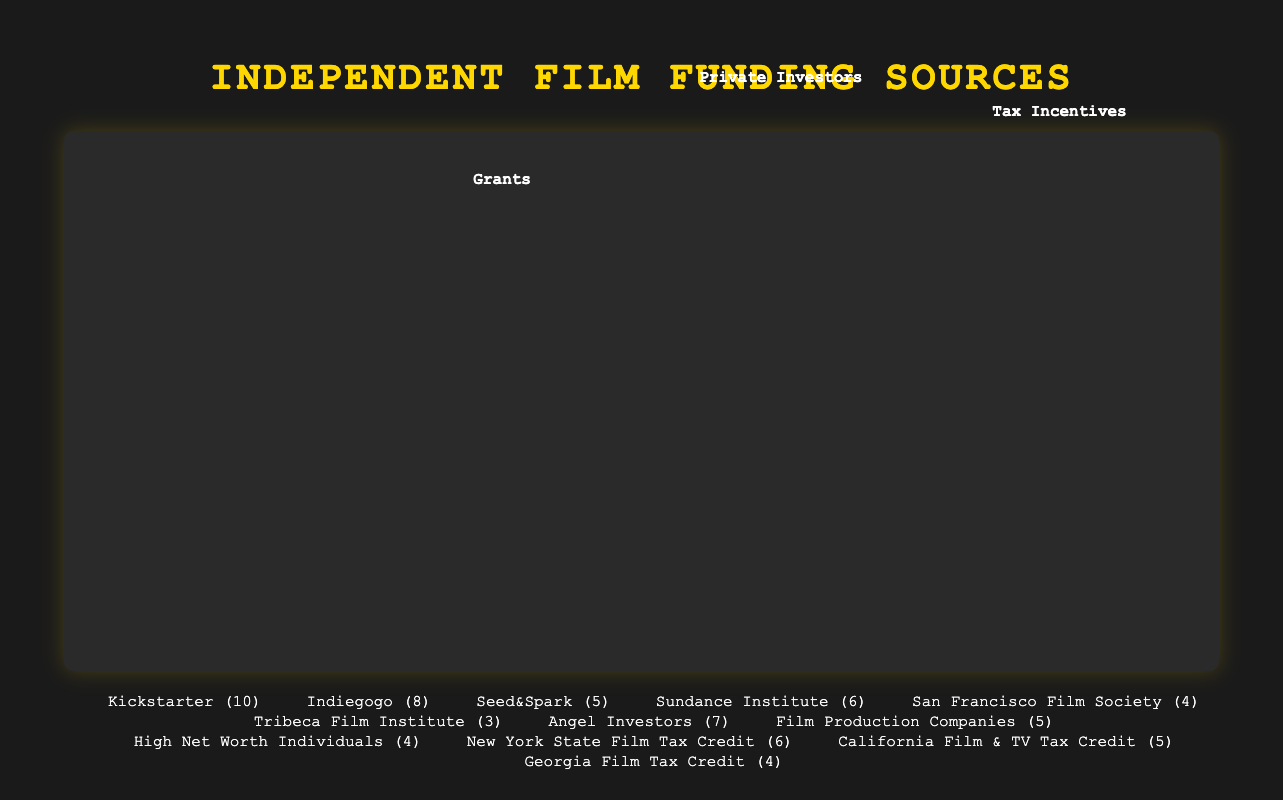How many platforms are shown under "Crowdfunding"? The "Crowdfunding" section includes platforms represented by the icons. By counting the distinct names in the legend or the stacks of icons, one can see that there are three platforms: Kickstarter, Indiegogo, and Seed&Spark.
Answer: 3 Which funding type has the least total contributions? By counting the total number of icons in each 'funding-type' stack, we find that "Grants" have 6 + 4 + 3 = 13, "Tax Incentives" have 6 + 5 + 4 = 15, "Private Investors" have 7 + 5 + 4 = 16, and "Crowdfunding" has 10 + 8 + 5 = 23. Therefore, "Grants" have the least total contributions.
Answer: Grants What's the difference in contributions between "Kickstarter" and "Indiegogo"? The legend specifies the counts directly: Kickstarter has 10 contributions, while Indiegogo has 8. The difference can be calculated as 10 - 8.
Answer: 2 How do the total contributions of "Tax Incentives" compare to those of "Grants"? For "Grants", the total is 6 + 4 + 3 = 13. For "Tax Incentives", the total is 6 + 5 + 4 = 15. Comparing these sums shows that "Tax Incentives" have more contributions than "Grants".
Answer: Tax Incentives have more Which crowd-funding platform has the highest count? In the "Crowdfunding" section, the counts for the platforms are shown in the legend or via the number of icons. Kickstarter has the highest count with 10 contributions.
Answer: Kickstarter What is the total number of contributions for all funding types combined? Sum up the total contributions of all types: Crowdfunding (10+8+5)=23, Grants (6+4+3)=13, Private Investors (7+5+4)=16, Tax Incentives (6+5+4)=15. The total is 23 + 13 + 16 + 15.
Answer: 67 If we sum the contributions of private investors, what do we get? The contributions from private investors consist of angel investors (7), film production companies (5), and high net worth individuals (4). Summing them, 7 + 5 + 4, gives the total.
Answer: 16 Does any funding source have a type where all categories are less than 6 contributions? Review the counts under each type. "Private Investors" has 7, 5, and 4, which means at least one count is 7, so it fails. "Grants" have counts of 6, 4, and 3, with one count, 6, which fails the condition. "Tax Incentives" have counts of 6, 5, and 4, also failing. "Crowdfunding" have counts of 10, 8, and 5, failing as well. Therefore, no funding source type meets this condition.
Answer: No 